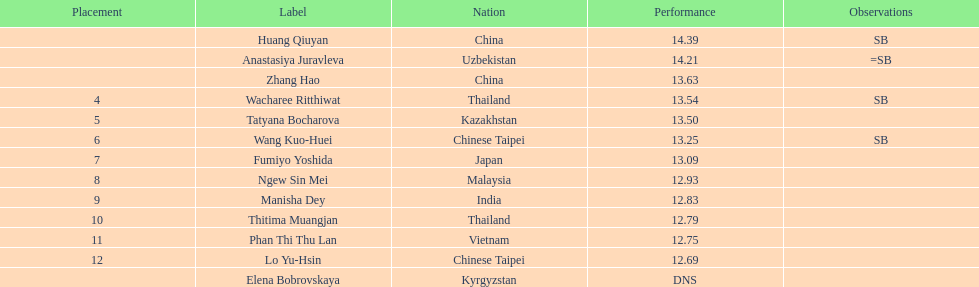How many athletes had a better result than tatyana bocharova? 4. 